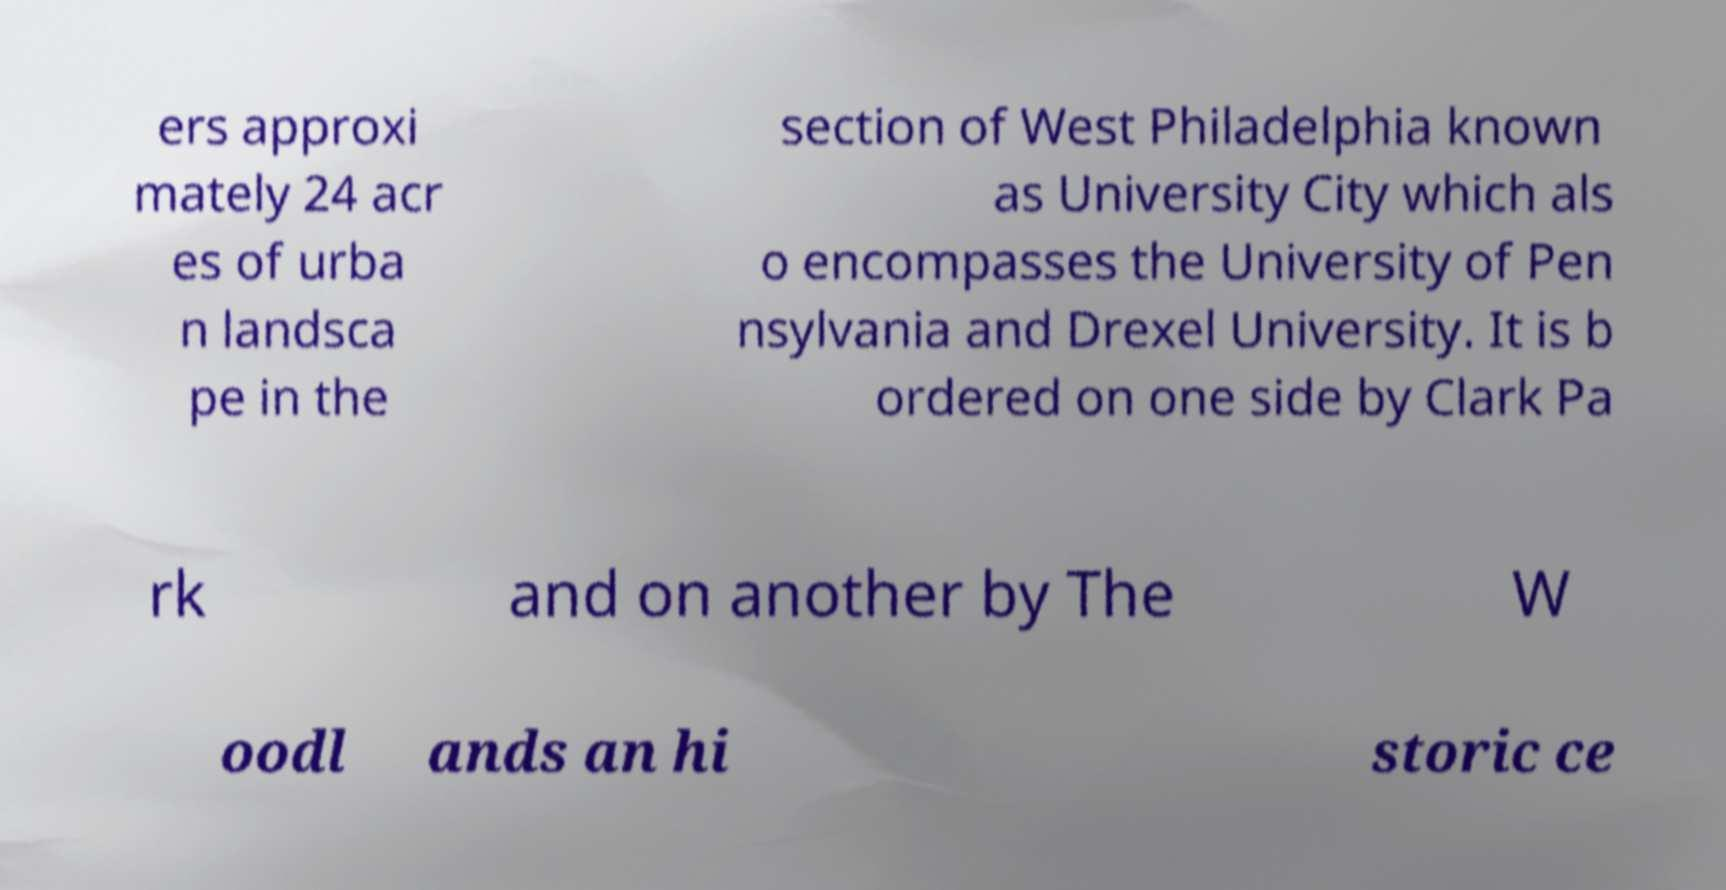There's text embedded in this image that I need extracted. Can you transcribe it verbatim? ers approxi mately 24 acr es of urba n landsca pe in the section of West Philadelphia known as University City which als o encompasses the University of Pen nsylvania and Drexel University. It is b ordered on one side by Clark Pa rk and on another by The W oodl ands an hi storic ce 